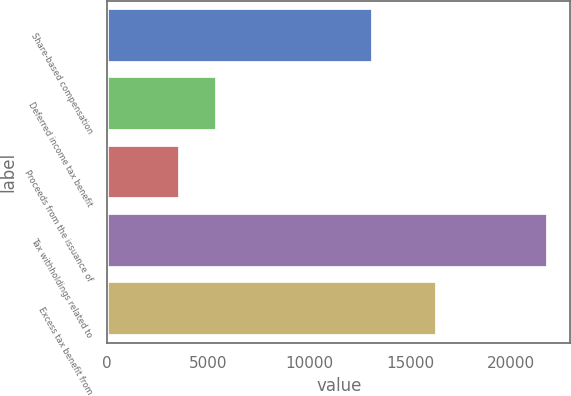<chart> <loc_0><loc_0><loc_500><loc_500><bar_chart><fcel>Share-based compensation<fcel>Deferred income tax benefit<fcel>Proceeds from the issuance of<fcel>Tax withholdings related to<fcel>Excess tax benefit from<nl><fcel>13191<fcel>5435.5<fcel>3611<fcel>21856<fcel>16320<nl></chart> 